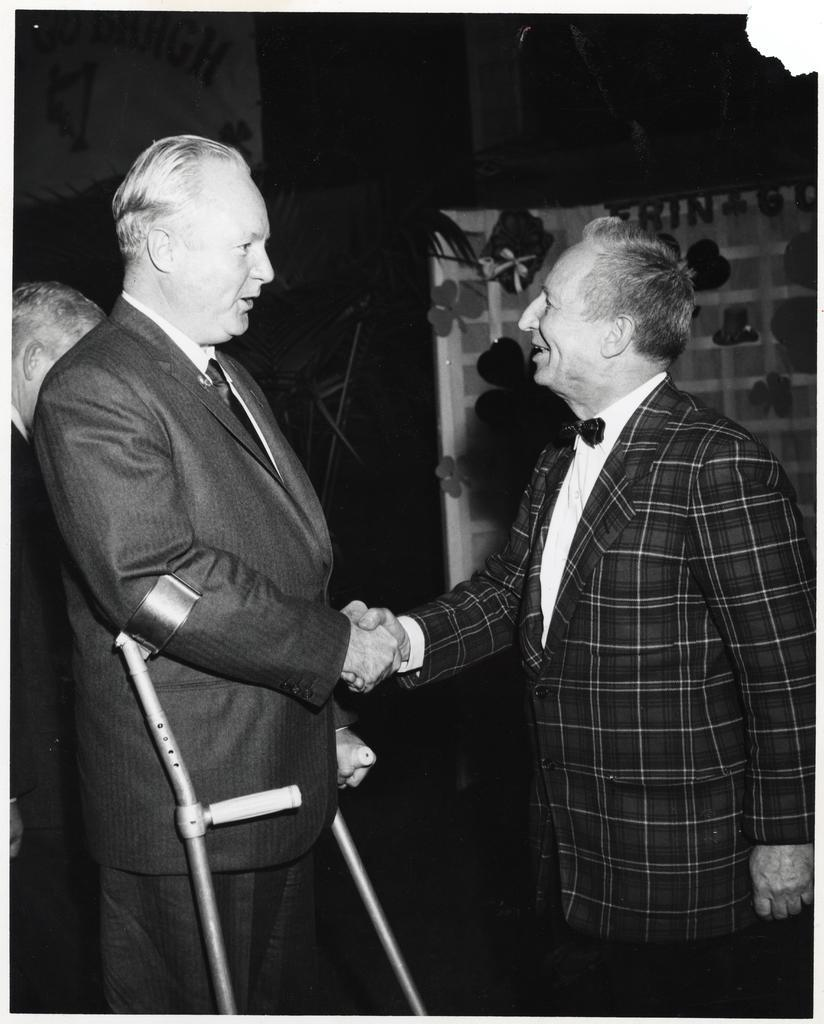How many people are present in the image? There are two men in the image. What are the men wearing? Both men are wearing blazers. What are the men doing in the image? The men are shaking hands. What can be seen in the background of the image? There is a curtain and a person standing in the background of the image. Can you see any fangs on the men in the image? There are no fangs visible on the men in the image. How many visitors are present in the image? The term "visitor" is not mentioned in the facts provided, so it cannot be determined from the image. 